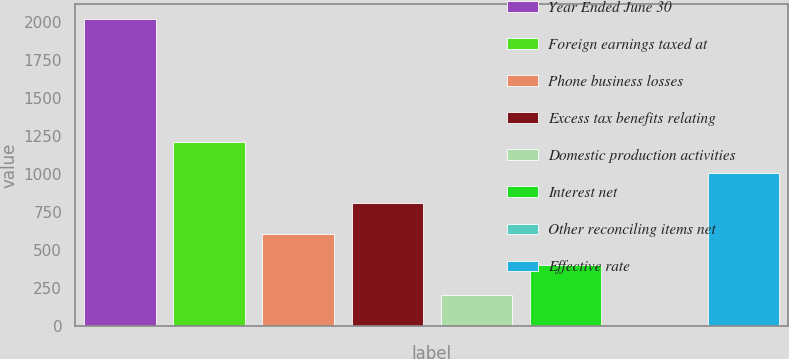Convert chart. <chart><loc_0><loc_0><loc_500><loc_500><bar_chart><fcel>Year Ended June 30<fcel>Foreign earnings taxed at<fcel>Phone business losses<fcel>Excess tax benefits relating<fcel>Domestic production activities<fcel>Interest net<fcel>Other reconciling items net<fcel>Effective rate<nl><fcel>2016<fcel>1209.8<fcel>605.15<fcel>806.7<fcel>202.05<fcel>403.6<fcel>0.5<fcel>1008.25<nl></chart> 